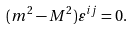<formula> <loc_0><loc_0><loc_500><loc_500>( m ^ { 2 } - M ^ { 2 } ) \varepsilon ^ { i j } = 0 .</formula> 